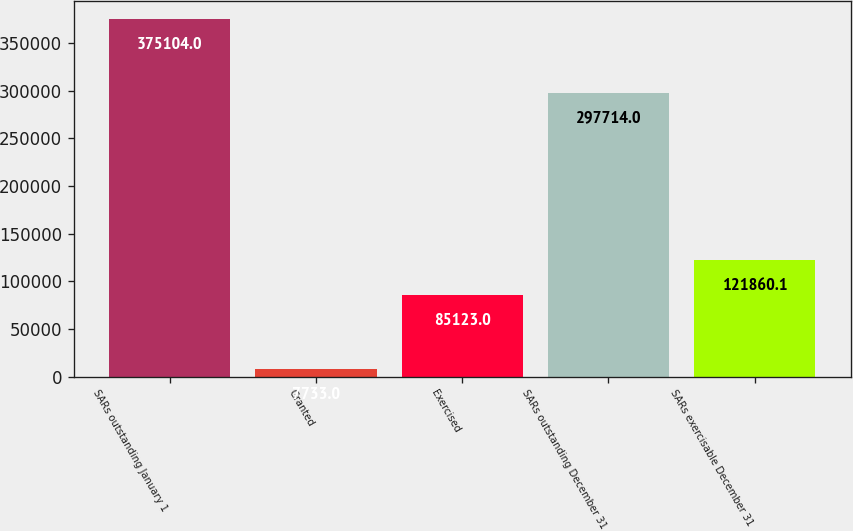Convert chart. <chart><loc_0><loc_0><loc_500><loc_500><bar_chart><fcel>SARs outstanding January 1<fcel>Granted<fcel>Exercised<fcel>SARs outstanding December 31<fcel>SARs exercisable December 31<nl><fcel>375104<fcel>7733<fcel>85123<fcel>297714<fcel>121860<nl></chart> 